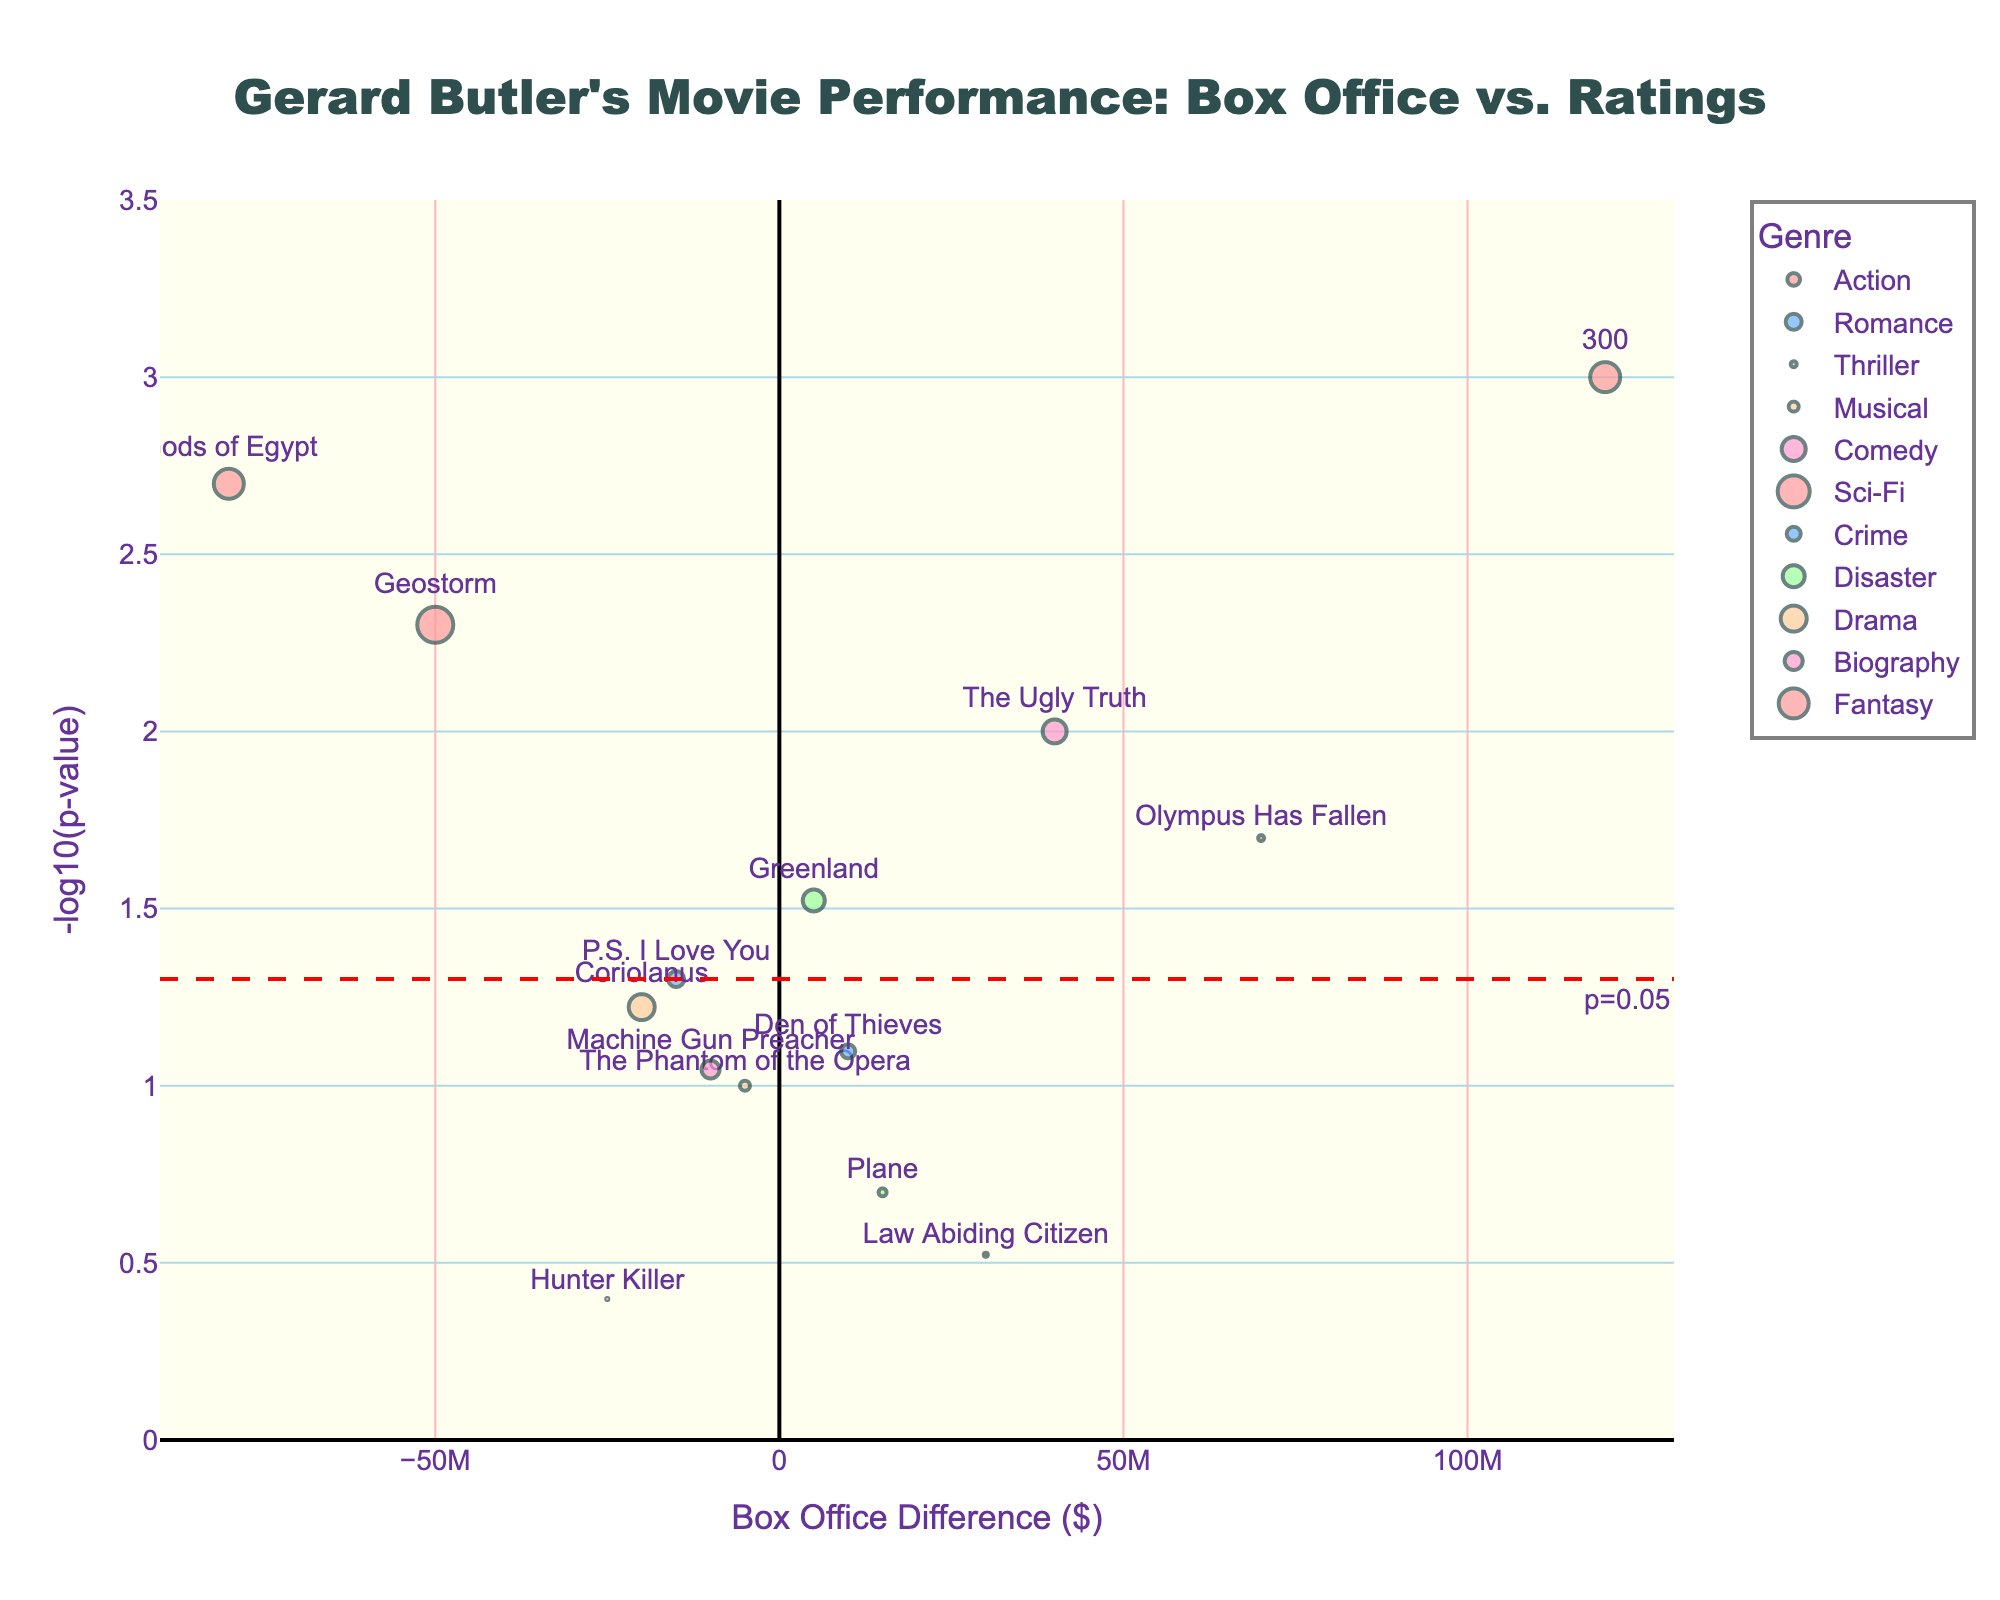what is the title of the plot? The title is usually located at the top center of the figure. Here, it reads, "Gerard Butler's Movie Performance: Box Office vs. Ratings", which provides a clear idea of what the plot represents.
Answer: Gerard Butler's Movie Performance: Box Office vs. Ratings What does the x-axis represent? The x-axis usually has a label that indicates what it represents. In this figure, the x-axis is labeled "Box Office Difference ($)", which suggests it shows the difference in box office performance of Gerard Butler's movies.
Answer: Box Office Difference ($) How is the y-axis labeled? The y-axis label can be found on the vertical line, and here, it reads "-log10(p-value)", which means it shows the negative logarithm of the significance value of the ratings difference.
Answer: -log10(p-value) What color represents the Action genre? Each genre is represented by a different color. By looking at the legend, we can see that the Action genre is represented by a shade of red.
Answer: A shade of red Which movie is in the Action genre and has the highest box office difference? We need to look at all the red-colored markers and identify which one is furthest to the right. "300" appears to be the one with the highest box office difference in the Action genre.
Answer: 300 Which movie has the lowest p-value? The lowest p-value corresponds to the highest y-value. By inspecting the plot, "300" in the Action genre has the highest y-value.
Answer: 300 Between "Geostorm" and "Gods of Egypt," which movie has a greater rating difference? We can check the size of the markers for both movies. "Geostorm" has a larger marker size compared to "Gods of Egypt." Thus, "Geostorm" has a greater rating difference.
Answer: Geostorm What is the significance level (p-value) threshold marked on the plot by the horizontal dashed line? The horizontal dashed line usually represents a common threshold for significance. Here, it is annotated as "p=0.05."
Answer: p=0.05 What can you infer about "P.S. I Love You" from its position in the plot? "P.S. I Love You" is below the horizontal dashed line (significance threshold), meaning its p-value is above 0.05. It is also left of the y-axis, indicating it had a lower box office difference. The small size suggests a minor to medium ratings difference.
Answer: p-value > 0.05, negative box office difference, medium ratings difference Which genre has the most movies with significant p-values? Movies with significant p-values are above the horizontal dashed line. We count the markers above the line for each genre as per their color: Action has three such movies ("300," "Olympus Has Fallen," and "Hunter Killer").
Answer: Action 